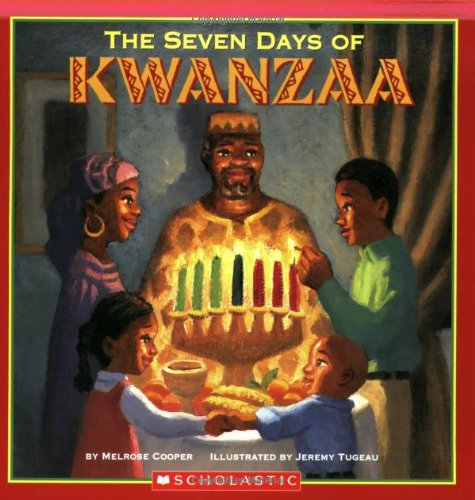Can you tell what type of illustrations are used in this book? The illustrations in this book are vibrant and colorful, done in a style that appears painterly, aiming to captivate and engage a young audience. 